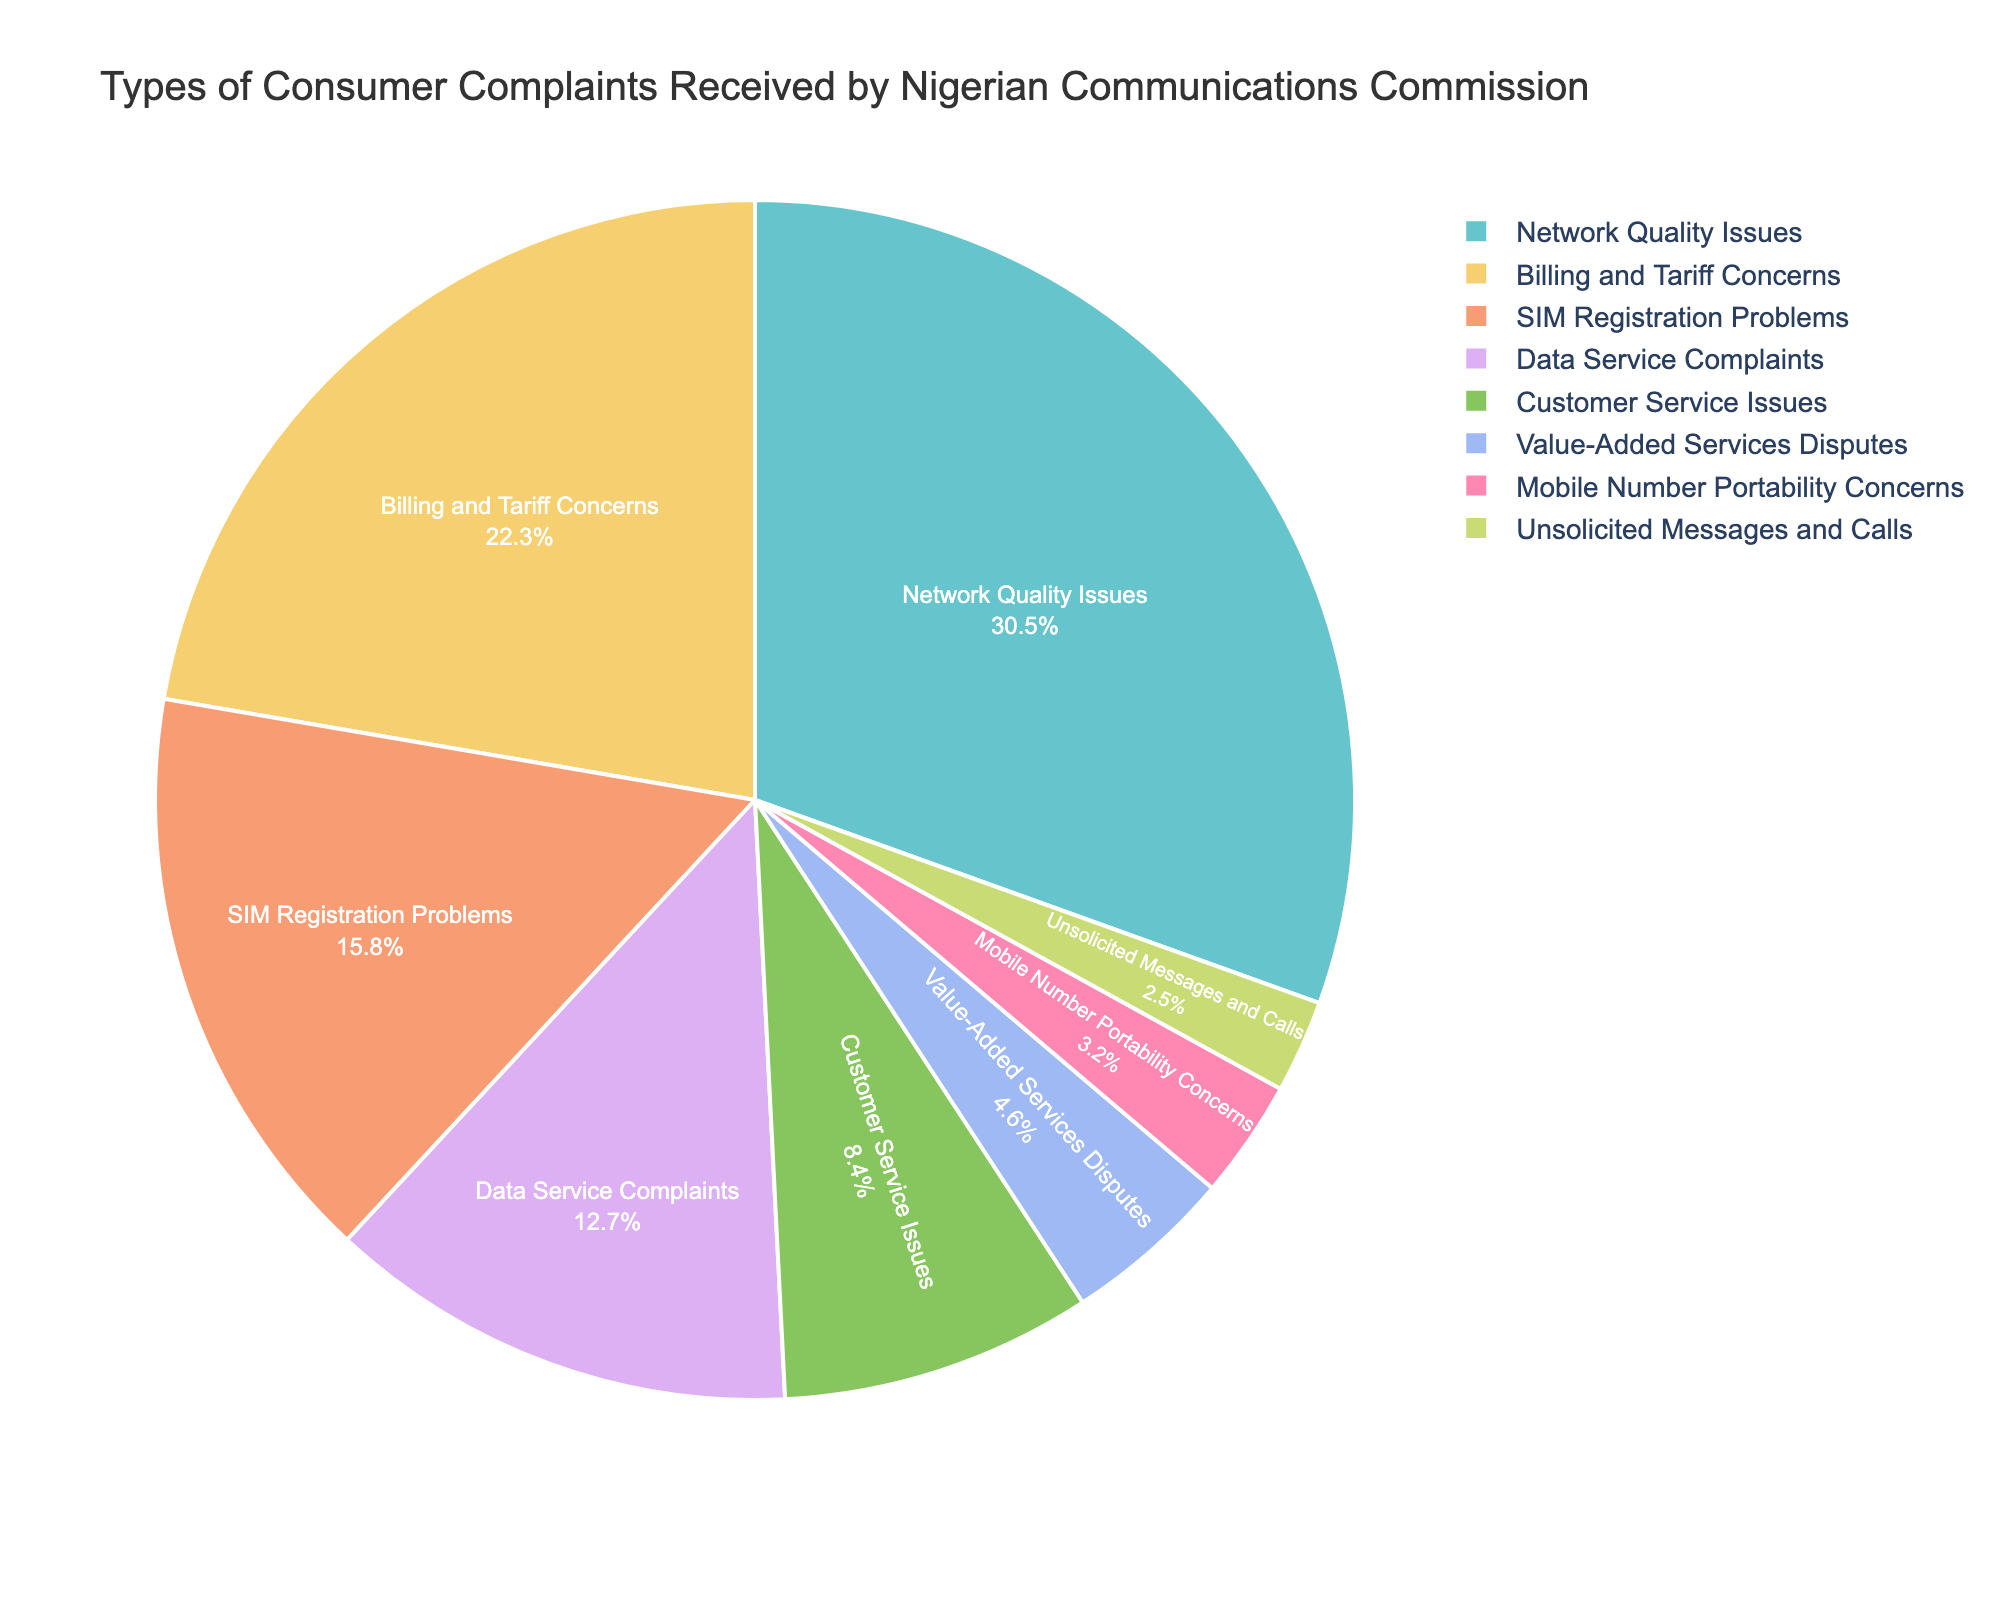Which type of consumer complaint has the highest percentage? From the pie chart, identify which complaint type occupies the largest segment. This is the type with the highest percentage.
Answer: Network Quality Issues Which type of consumer complaint has the lowest percentage? From the pie chart, identify which complaint type occupies the smallest segment. This is the type with the lowest percentage.
Answer: Unsolicited Messages and Calls What is the combined percentage of Billing and Tariff Concerns and Data Service Complaints? Add the percentages of both Billing and Tariff Concerns (22.3%) and Data Service Complaints (12.7%) to get the combined percentage. 22.3 + 12.7 = 35
Answer: 35 Which type of complaint has a higher percentage: Customer Service Issues or SIM Registration Problems? Compare the percentages of Customer Service Issues (8.4%) and SIM Registration Problems (15.8%). 15.8 is higher than 8.4.
Answer: SIM Registration Problems What is the total percentage of complaints related to Network Quality Issues and Value-Added Services Disputes? Sum the percentages of Network Quality Issues (30.5%) and Value-Added Services Disputes (4.6%). 30.5 + 4.6 = 35.1
Answer: 35.1 Is the percentage of Customer Service Issues greater than or less than 10%? Check the percentage for Customer Service Issues (8.4%) and determine if it is greater than or less than 10%. 8.4 is less than 10.
Answer: Less Which two complaint types together form nearly half of the total complaints? Identify two complaint types whose combined percentage approaches 50%. Network Quality Issues (30.5%) and Billing and Tariff Concerns (22.3%) together sum to 52.8%.
Answer: Network Quality Issues and Billing and Tariff Concerns By how much does the percentage of Network Quality Issues exceed that of Data Service Complaints? Subtract the percentage of Data Service Complaints (12.7%) from Network Quality Issues (30.5%). 30.5 - 12.7 = 17.8
Answer: 17.8 What percentage of complaints does SIM Registration Problems and Mobile Number Portability Concerns make up together? Add the percentages of SIM Registration Problems (15.8%) and Mobile Number Portability Concerns (3.2%). 15.8 + 3.2 = 19
Answer: 19 Are Value-Added Services Disputes or Unsolicited Messages and Calls more common? Compare the percentages of Value-Added Services Disputes (4.6%) and Unsolicited Messages and Calls (2.5%). 4.6 is greater than 2.5.
Answer: Value-Added Services Disputes 